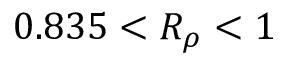<formula> <loc_0><loc_0><loc_500><loc_500>0 . 8 3 5 < R _ { \rho } < 1</formula> 